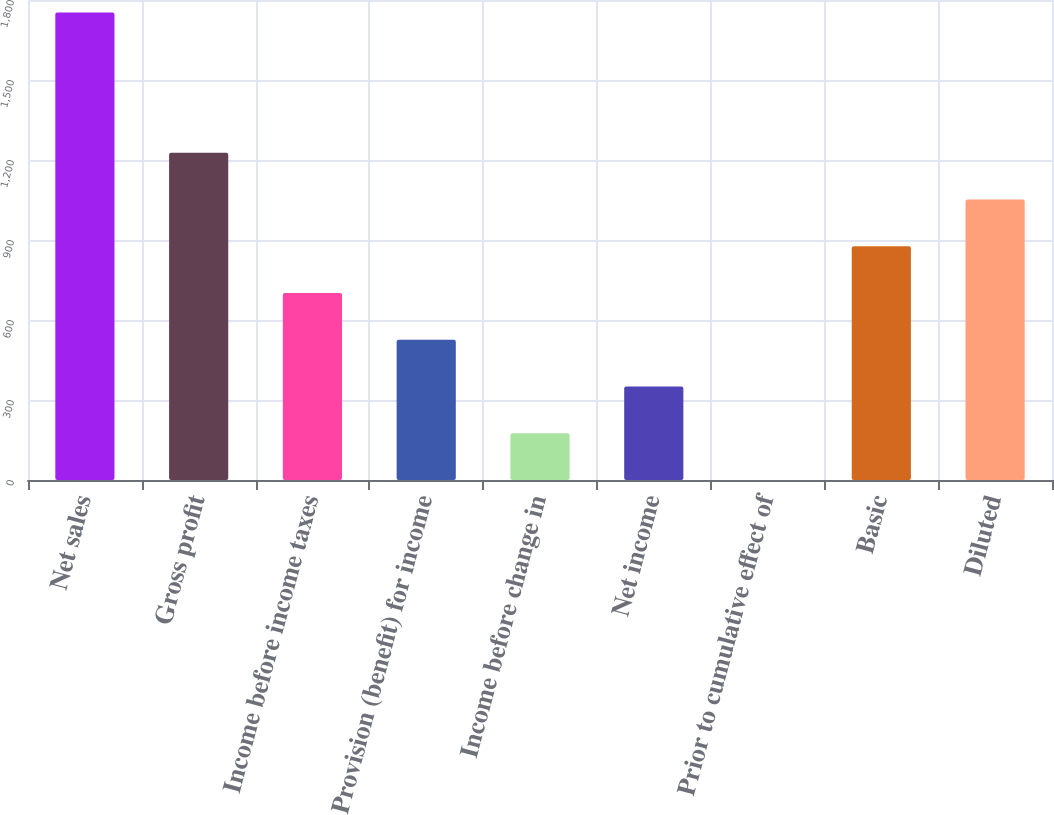<chart> <loc_0><loc_0><loc_500><loc_500><bar_chart><fcel>Net sales<fcel>Gross profit<fcel>Income before income taxes<fcel>Provision (benefit) for income<fcel>Income before change in<fcel>Net income<fcel>Prior to cumulative effect of<fcel>Basic<fcel>Diluted<nl><fcel>1753<fcel>1227.16<fcel>701.29<fcel>526<fcel>175.42<fcel>350.71<fcel>0.13<fcel>876.58<fcel>1051.87<nl></chart> 